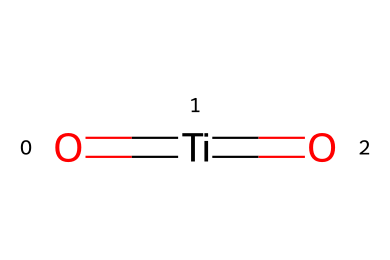What is the central atom in this molecule? In the SMILES representation, the atom is represented by "Ti," which indicates titanium is the central atom in this molecular structure.
Answer: titanium How many oxygen atoms are present in this compound? The representation shows two oxygen atoms, which are denoted by the "O" in the SMILES string.
Answer: two What type of bonds are present in titanium dioxide? The structure showcases double bonds between the titanium atom and both oxygen atoms, indicated by the "=" sign in the SMILES notation.
Answer: double bonds What is the molecular formula of this compound? The SMILES representation implies one titanium atom and two oxygen atoms, leading to the molecular formula TiO2 for titanium dioxide.
Answer: TiO2 What is the oxidation state of titanium in this compound? Because titanium in this structure is shown with a double bond to two oxygen atoms, it typically exhibits an oxidation state of +4.
Answer: +4 What property of titanium dioxide makes it useful in protective coatings? Titanium dioxide is known for its photocatalytic properties and UV resistance, which enhance the durability of coatings.
Answer: photocatalytic properties What is the primary application of TiO2 in sports-related protective coatings? TiO2 is widely used for its ability to provide UV protection and enhance durability in coatings used in sports equipment.
Answer: UV protection 